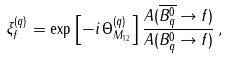Convert formula to latex. <formula><loc_0><loc_0><loc_500><loc_500>\xi _ { f } ^ { ( q ) } = \exp \left [ - i \, \Theta _ { M _ { 1 2 } } ^ { ( q ) } \right ] \frac { A ( \overline { B ^ { 0 } _ { q } } \to f ) } { A ( B ^ { 0 } _ { q } \to f ) } \, ,</formula> 